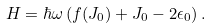Convert formula to latex. <formula><loc_0><loc_0><loc_500><loc_500>H = \hbar { \omega } \left ( f ( J _ { 0 } ) + J _ { 0 } - 2 \epsilon _ { 0 } \right ) .</formula> 